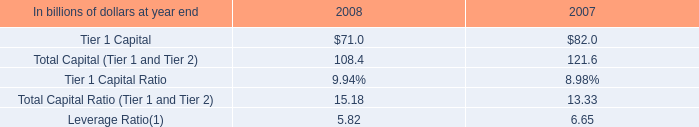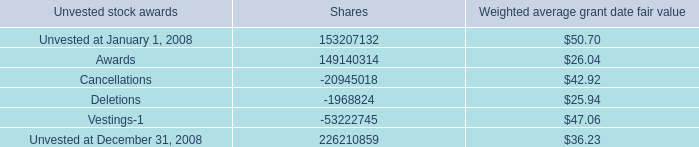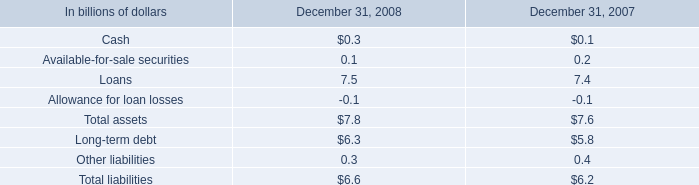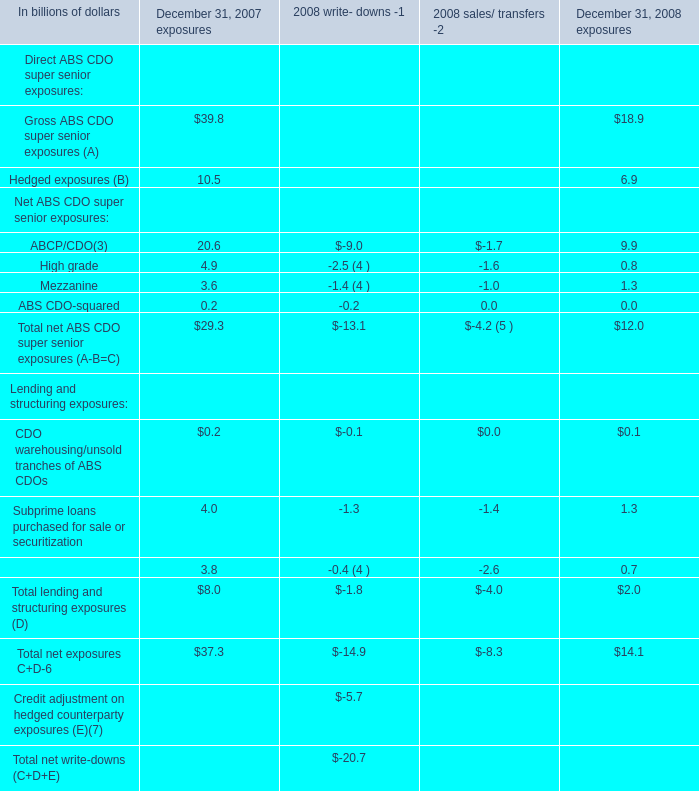what was the percentage increase in the total assets from 2007 to 2008 
Computations: ((7.8 - 7.6) / 7.6)
Answer: 0.02632. 